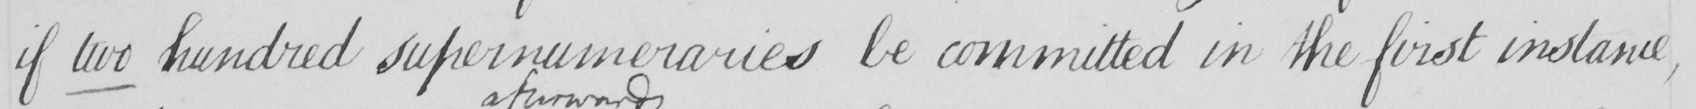Please provide the text content of this handwritten line. if two hundred supernumeraries be committed in the first instance , 